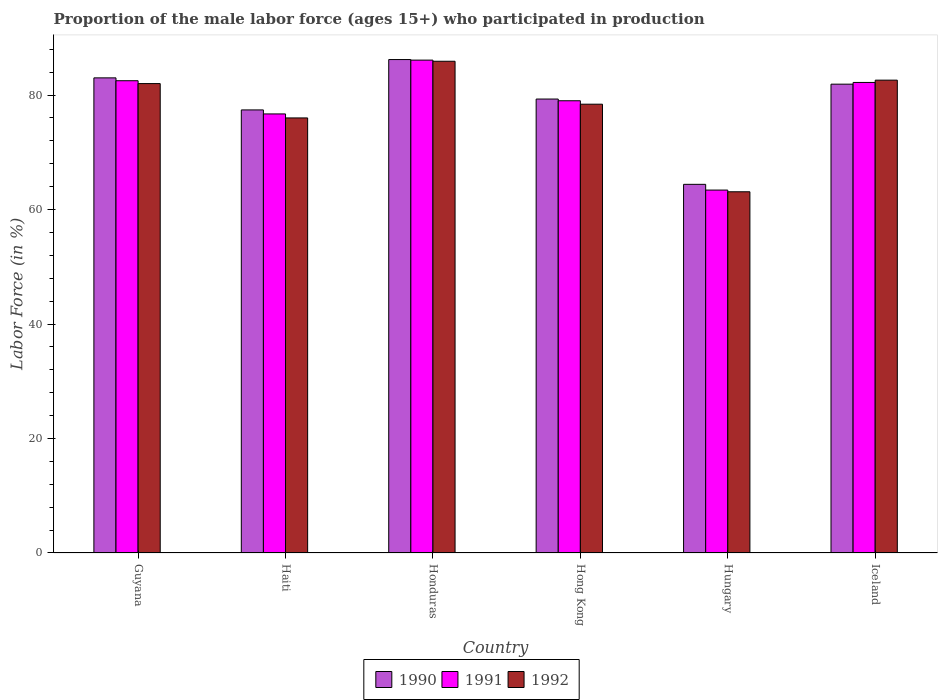How many different coloured bars are there?
Your answer should be very brief. 3. How many groups of bars are there?
Offer a terse response. 6. How many bars are there on the 2nd tick from the left?
Offer a terse response. 3. What is the label of the 2nd group of bars from the left?
Provide a short and direct response. Haiti. What is the proportion of the male labor force who participated in production in 1990 in Hong Kong?
Ensure brevity in your answer.  79.3. Across all countries, what is the maximum proportion of the male labor force who participated in production in 1990?
Provide a succinct answer. 86.2. Across all countries, what is the minimum proportion of the male labor force who participated in production in 1992?
Your answer should be very brief. 63.1. In which country was the proportion of the male labor force who participated in production in 1991 maximum?
Provide a succinct answer. Honduras. In which country was the proportion of the male labor force who participated in production in 1991 minimum?
Your answer should be very brief. Hungary. What is the total proportion of the male labor force who participated in production in 1991 in the graph?
Provide a short and direct response. 469.9. What is the difference between the proportion of the male labor force who participated in production in 1992 in Hong Kong and that in Iceland?
Offer a very short reply. -4.2. What is the difference between the proportion of the male labor force who participated in production in 1991 in Hungary and the proportion of the male labor force who participated in production in 1992 in Hong Kong?
Give a very brief answer. -15. What is the average proportion of the male labor force who participated in production in 1991 per country?
Your response must be concise. 78.32. What is the difference between the proportion of the male labor force who participated in production of/in 1991 and proportion of the male labor force who participated in production of/in 1992 in Honduras?
Offer a very short reply. 0.2. In how many countries, is the proportion of the male labor force who participated in production in 1990 greater than 12 %?
Offer a terse response. 6. What is the ratio of the proportion of the male labor force who participated in production in 1990 in Guyana to that in Iceland?
Provide a succinct answer. 1.01. Is the proportion of the male labor force who participated in production in 1990 in Honduras less than that in Hungary?
Offer a very short reply. No. Is the difference between the proportion of the male labor force who participated in production in 1991 in Hungary and Iceland greater than the difference between the proportion of the male labor force who participated in production in 1992 in Hungary and Iceland?
Your answer should be compact. Yes. What is the difference between the highest and the second highest proportion of the male labor force who participated in production in 1991?
Offer a very short reply. 0.3. What is the difference between the highest and the lowest proportion of the male labor force who participated in production in 1990?
Ensure brevity in your answer.  21.8. Is the sum of the proportion of the male labor force who participated in production in 1991 in Honduras and Hong Kong greater than the maximum proportion of the male labor force who participated in production in 1990 across all countries?
Ensure brevity in your answer.  Yes. What does the 1st bar from the right in Honduras represents?
Your response must be concise. 1992. Is it the case that in every country, the sum of the proportion of the male labor force who participated in production in 1990 and proportion of the male labor force who participated in production in 1992 is greater than the proportion of the male labor force who participated in production in 1991?
Offer a very short reply. Yes. How many bars are there?
Offer a terse response. 18. Are all the bars in the graph horizontal?
Your answer should be compact. No. Does the graph contain any zero values?
Give a very brief answer. No. How many legend labels are there?
Provide a short and direct response. 3. How are the legend labels stacked?
Offer a very short reply. Horizontal. What is the title of the graph?
Offer a terse response. Proportion of the male labor force (ages 15+) who participated in production. What is the label or title of the X-axis?
Your answer should be compact. Country. What is the Labor Force (in %) of 1990 in Guyana?
Provide a succinct answer. 83. What is the Labor Force (in %) of 1991 in Guyana?
Give a very brief answer. 82.5. What is the Labor Force (in %) in 1990 in Haiti?
Ensure brevity in your answer.  77.4. What is the Labor Force (in %) in 1991 in Haiti?
Your answer should be very brief. 76.7. What is the Labor Force (in %) of 1992 in Haiti?
Your answer should be compact. 76. What is the Labor Force (in %) in 1990 in Honduras?
Offer a terse response. 86.2. What is the Labor Force (in %) of 1991 in Honduras?
Provide a short and direct response. 86.1. What is the Labor Force (in %) in 1992 in Honduras?
Ensure brevity in your answer.  85.9. What is the Labor Force (in %) in 1990 in Hong Kong?
Offer a very short reply. 79.3. What is the Labor Force (in %) of 1991 in Hong Kong?
Make the answer very short. 79. What is the Labor Force (in %) of 1992 in Hong Kong?
Ensure brevity in your answer.  78.4. What is the Labor Force (in %) of 1990 in Hungary?
Offer a terse response. 64.4. What is the Labor Force (in %) of 1991 in Hungary?
Offer a very short reply. 63.4. What is the Labor Force (in %) of 1992 in Hungary?
Offer a very short reply. 63.1. What is the Labor Force (in %) in 1990 in Iceland?
Keep it short and to the point. 81.9. What is the Labor Force (in %) in 1991 in Iceland?
Your response must be concise. 82.2. What is the Labor Force (in %) in 1992 in Iceland?
Provide a short and direct response. 82.6. Across all countries, what is the maximum Labor Force (in %) in 1990?
Ensure brevity in your answer.  86.2. Across all countries, what is the maximum Labor Force (in %) in 1991?
Your answer should be compact. 86.1. Across all countries, what is the maximum Labor Force (in %) in 1992?
Provide a succinct answer. 85.9. Across all countries, what is the minimum Labor Force (in %) in 1990?
Make the answer very short. 64.4. Across all countries, what is the minimum Labor Force (in %) of 1991?
Make the answer very short. 63.4. Across all countries, what is the minimum Labor Force (in %) of 1992?
Offer a very short reply. 63.1. What is the total Labor Force (in %) of 1990 in the graph?
Offer a terse response. 472.2. What is the total Labor Force (in %) in 1991 in the graph?
Your response must be concise. 469.9. What is the total Labor Force (in %) in 1992 in the graph?
Keep it short and to the point. 468. What is the difference between the Labor Force (in %) of 1992 in Guyana and that in Haiti?
Ensure brevity in your answer.  6. What is the difference between the Labor Force (in %) in 1991 in Guyana and that in Hong Kong?
Give a very brief answer. 3.5. What is the difference between the Labor Force (in %) of 1992 in Guyana and that in Hong Kong?
Provide a short and direct response. 3.6. What is the difference between the Labor Force (in %) of 1990 in Guyana and that in Hungary?
Keep it short and to the point. 18.6. What is the difference between the Labor Force (in %) of 1992 in Guyana and that in Hungary?
Make the answer very short. 18.9. What is the difference between the Labor Force (in %) in 1990 in Guyana and that in Iceland?
Make the answer very short. 1.1. What is the difference between the Labor Force (in %) in 1991 in Guyana and that in Iceland?
Ensure brevity in your answer.  0.3. What is the difference between the Labor Force (in %) of 1990 in Haiti and that in Honduras?
Provide a succinct answer. -8.8. What is the difference between the Labor Force (in %) in 1992 in Haiti and that in Honduras?
Give a very brief answer. -9.9. What is the difference between the Labor Force (in %) in 1991 in Haiti and that in Hong Kong?
Offer a terse response. -2.3. What is the difference between the Labor Force (in %) of 1990 in Haiti and that in Hungary?
Give a very brief answer. 13. What is the difference between the Labor Force (in %) in 1991 in Haiti and that in Hungary?
Make the answer very short. 13.3. What is the difference between the Labor Force (in %) in 1992 in Haiti and that in Hungary?
Ensure brevity in your answer.  12.9. What is the difference between the Labor Force (in %) in 1990 in Haiti and that in Iceland?
Provide a short and direct response. -4.5. What is the difference between the Labor Force (in %) in 1991 in Haiti and that in Iceland?
Ensure brevity in your answer.  -5.5. What is the difference between the Labor Force (in %) of 1990 in Honduras and that in Hungary?
Your answer should be very brief. 21.8. What is the difference between the Labor Force (in %) of 1991 in Honduras and that in Hungary?
Your response must be concise. 22.7. What is the difference between the Labor Force (in %) in 1992 in Honduras and that in Hungary?
Offer a terse response. 22.8. What is the difference between the Labor Force (in %) in 1991 in Honduras and that in Iceland?
Provide a succinct answer. 3.9. What is the difference between the Labor Force (in %) in 1990 in Hong Kong and that in Hungary?
Offer a very short reply. 14.9. What is the difference between the Labor Force (in %) of 1992 in Hong Kong and that in Hungary?
Your answer should be very brief. 15.3. What is the difference between the Labor Force (in %) in 1990 in Hong Kong and that in Iceland?
Your response must be concise. -2.6. What is the difference between the Labor Force (in %) of 1991 in Hong Kong and that in Iceland?
Provide a short and direct response. -3.2. What is the difference between the Labor Force (in %) in 1992 in Hong Kong and that in Iceland?
Provide a short and direct response. -4.2. What is the difference between the Labor Force (in %) in 1990 in Hungary and that in Iceland?
Keep it short and to the point. -17.5. What is the difference between the Labor Force (in %) in 1991 in Hungary and that in Iceland?
Give a very brief answer. -18.8. What is the difference between the Labor Force (in %) of 1992 in Hungary and that in Iceland?
Make the answer very short. -19.5. What is the difference between the Labor Force (in %) in 1990 in Guyana and the Labor Force (in %) in 1992 in Haiti?
Offer a terse response. 7. What is the difference between the Labor Force (in %) of 1990 in Guyana and the Labor Force (in %) of 1991 in Honduras?
Give a very brief answer. -3.1. What is the difference between the Labor Force (in %) in 1991 in Guyana and the Labor Force (in %) in 1992 in Honduras?
Provide a short and direct response. -3.4. What is the difference between the Labor Force (in %) in 1990 in Guyana and the Labor Force (in %) in 1991 in Hungary?
Provide a succinct answer. 19.6. What is the difference between the Labor Force (in %) of 1991 in Guyana and the Labor Force (in %) of 1992 in Hungary?
Give a very brief answer. 19.4. What is the difference between the Labor Force (in %) in 1990 in Guyana and the Labor Force (in %) in 1992 in Iceland?
Keep it short and to the point. 0.4. What is the difference between the Labor Force (in %) in 1991 in Haiti and the Labor Force (in %) in 1992 in Honduras?
Provide a succinct answer. -9.2. What is the difference between the Labor Force (in %) of 1990 in Haiti and the Labor Force (in %) of 1992 in Hong Kong?
Your answer should be compact. -1. What is the difference between the Labor Force (in %) in 1991 in Haiti and the Labor Force (in %) in 1992 in Hong Kong?
Make the answer very short. -1.7. What is the difference between the Labor Force (in %) of 1991 in Haiti and the Labor Force (in %) of 1992 in Hungary?
Give a very brief answer. 13.6. What is the difference between the Labor Force (in %) in 1991 in Haiti and the Labor Force (in %) in 1992 in Iceland?
Provide a short and direct response. -5.9. What is the difference between the Labor Force (in %) of 1990 in Honduras and the Labor Force (in %) of 1991 in Hong Kong?
Provide a succinct answer. 7.2. What is the difference between the Labor Force (in %) of 1990 in Honduras and the Labor Force (in %) of 1992 in Hong Kong?
Give a very brief answer. 7.8. What is the difference between the Labor Force (in %) in 1990 in Honduras and the Labor Force (in %) in 1991 in Hungary?
Your response must be concise. 22.8. What is the difference between the Labor Force (in %) in 1990 in Honduras and the Labor Force (in %) in 1992 in Hungary?
Keep it short and to the point. 23.1. What is the difference between the Labor Force (in %) of 1991 in Honduras and the Labor Force (in %) of 1992 in Hungary?
Offer a terse response. 23. What is the difference between the Labor Force (in %) in 1990 in Honduras and the Labor Force (in %) in 1991 in Iceland?
Ensure brevity in your answer.  4. What is the difference between the Labor Force (in %) in 1990 in Honduras and the Labor Force (in %) in 1992 in Iceland?
Keep it short and to the point. 3.6. What is the difference between the Labor Force (in %) of 1990 in Hong Kong and the Labor Force (in %) of 1992 in Hungary?
Your answer should be compact. 16.2. What is the difference between the Labor Force (in %) in 1991 in Hong Kong and the Labor Force (in %) in 1992 in Hungary?
Give a very brief answer. 15.9. What is the difference between the Labor Force (in %) of 1990 in Hong Kong and the Labor Force (in %) of 1991 in Iceland?
Ensure brevity in your answer.  -2.9. What is the difference between the Labor Force (in %) in 1990 in Hong Kong and the Labor Force (in %) in 1992 in Iceland?
Offer a very short reply. -3.3. What is the difference between the Labor Force (in %) of 1991 in Hong Kong and the Labor Force (in %) of 1992 in Iceland?
Offer a terse response. -3.6. What is the difference between the Labor Force (in %) of 1990 in Hungary and the Labor Force (in %) of 1991 in Iceland?
Offer a very short reply. -17.8. What is the difference between the Labor Force (in %) in 1990 in Hungary and the Labor Force (in %) in 1992 in Iceland?
Make the answer very short. -18.2. What is the difference between the Labor Force (in %) of 1991 in Hungary and the Labor Force (in %) of 1992 in Iceland?
Your response must be concise. -19.2. What is the average Labor Force (in %) of 1990 per country?
Keep it short and to the point. 78.7. What is the average Labor Force (in %) in 1991 per country?
Give a very brief answer. 78.32. What is the difference between the Labor Force (in %) in 1990 and Labor Force (in %) in 1992 in Haiti?
Your response must be concise. 1.4. What is the difference between the Labor Force (in %) of 1990 and Labor Force (in %) of 1992 in Honduras?
Your answer should be very brief. 0.3. What is the difference between the Labor Force (in %) in 1991 and Labor Force (in %) in 1992 in Honduras?
Your answer should be compact. 0.2. What is the difference between the Labor Force (in %) in 1990 and Labor Force (in %) in 1991 in Hong Kong?
Provide a short and direct response. 0.3. What is the difference between the Labor Force (in %) in 1990 and Labor Force (in %) in 1991 in Hungary?
Provide a succinct answer. 1. What is the difference between the Labor Force (in %) of 1990 and Labor Force (in %) of 1992 in Hungary?
Provide a succinct answer. 1.3. What is the difference between the Labor Force (in %) of 1991 and Labor Force (in %) of 1992 in Hungary?
Ensure brevity in your answer.  0.3. What is the difference between the Labor Force (in %) in 1990 and Labor Force (in %) in 1991 in Iceland?
Make the answer very short. -0.3. What is the ratio of the Labor Force (in %) of 1990 in Guyana to that in Haiti?
Your response must be concise. 1.07. What is the ratio of the Labor Force (in %) of 1991 in Guyana to that in Haiti?
Your answer should be compact. 1.08. What is the ratio of the Labor Force (in %) of 1992 in Guyana to that in Haiti?
Offer a very short reply. 1.08. What is the ratio of the Labor Force (in %) in 1990 in Guyana to that in Honduras?
Your answer should be compact. 0.96. What is the ratio of the Labor Force (in %) in 1991 in Guyana to that in Honduras?
Ensure brevity in your answer.  0.96. What is the ratio of the Labor Force (in %) in 1992 in Guyana to that in Honduras?
Offer a terse response. 0.95. What is the ratio of the Labor Force (in %) in 1990 in Guyana to that in Hong Kong?
Your answer should be very brief. 1.05. What is the ratio of the Labor Force (in %) of 1991 in Guyana to that in Hong Kong?
Make the answer very short. 1.04. What is the ratio of the Labor Force (in %) in 1992 in Guyana to that in Hong Kong?
Ensure brevity in your answer.  1.05. What is the ratio of the Labor Force (in %) in 1990 in Guyana to that in Hungary?
Ensure brevity in your answer.  1.29. What is the ratio of the Labor Force (in %) of 1991 in Guyana to that in Hungary?
Your response must be concise. 1.3. What is the ratio of the Labor Force (in %) in 1992 in Guyana to that in Hungary?
Keep it short and to the point. 1.3. What is the ratio of the Labor Force (in %) in 1990 in Guyana to that in Iceland?
Your answer should be compact. 1.01. What is the ratio of the Labor Force (in %) of 1990 in Haiti to that in Honduras?
Give a very brief answer. 0.9. What is the ratio of the Labor Force (in %) in 1991 in Haiti to that in Honduras?
Make the answer very short. 0.89. What is the ratio of the Labor Force (in %) of 1992 in Haiti to that in Honduras?
Your response must be concise. 0.88. What is the ratio of the Labor Force (in %) of 1991 in Haiti to that in Hong Kong?
Provide a short and direct response. 0.97. What is the ratio of the Labor Force (in %) of 1992 in Haiti to that in Hong Kong?
Give a very brief answer. 0.97. What is the ratio of the Labor Force (in %) of 1990 in Haiti to that in Hungary?
Keep it short and to the point. 1.2. What is the ratio of the Labor Force (in %) in 1991 in Haiti to that in Hungary?
Keep it short and to the point. 1.21. What is the ratio of the Labor Force (in %) in 1992 in Haiti to that in Hungary?
Provide a short and direct response. 1.2. What is the ratio of the Labor Force (in %) in 1990 in Haiti to that in Iceland?
Provide a succinct answer. 0.95. What is the ratio of the Labor Force (in %) in 1991 in Haiti to that in Iceland?
Give a very brief answer. 0.93. What is the ratio of the Labor Force (in %) in 1992 in Haiti to that in Iceland?
Make the answer very short. 0.92. What is the ratio of the Labor Force (in %) of 1990 in Honduras to that in Hong Kong?
Your answer should be compact. 1.09. What is the ratio of the Labor Force (in %) of 1991 in Honduras to that in Hong Kong?
Give a very brief answer. 1.09. What is the ratio of the Labor Force (in %) of 1992 in Honduras to that in Hong Kong?
Your response must be concise. 1.1. What is the ratio of the Labor Force (in %) of 1990 in Honduras to that in Hungary?
Give a very brief answer. 1.34. What is the ratio of the Labor Force (in %) in 1991 in Honduras to that in Hungary?
Keep it short and to the point. 1.36. What is the ratio of the Labor Force (in %) in 1992 in Honduras to that in Hungary?
Make the answer very short. 1.36. What is the ratio of the Labor Force (in %) in 1990 in Honduras to that in Iceland?
Offer a terse response. 1.05. What is the ratio of the Labor Force (in %) of 1991 in Honduras to that in Iceland?
Your answer should be very brief. 1.05. What is the ratio of the Labor Force (in %) in 1992 in Honduras to that in Iceland?
Give a very brief answer. 1.04. What is the ratio of the Labor Force (in %) of 1990 in Hong Kong to that in Hungary?
Offer a very short reply. 1.23. What is the ratio of the Labor Force (in %) in 1991 in Hong Kong to that in Hungary?
Ensure brevity in your answer.  1.25. What is the ratio of the Labor Force (in %) in 1992 in Hong Kong to that in Hungary?
Your answer should be compact. 1.24. What is the ratio of the Labor Force (in %) in 1990 in Hong Kong to that in Iceland?
Make the answer very short. 0.97. What is the ratio of the Labor Force (in %) of 1991 in Hong Kong to that in Iceland?
Your response must be concise. 0.96. What is the ratio of the Labor Force (in %) in 1992 in Hong Kong to that in Iceland?
Offer a very short reply. 0.95. What is the ratio of the Labor Force (in %) of 1990 in Hungary to that in Iceland?
Make the answer very short. 0.79. What is the ratio of the Labor Force (in %) of 1991 in Hungary to that in Iceland?
Give a very brief answer. 0.77. What is the ratio of the Labor Force (in %) in 1992 in Hungary to that in Iceland?
Provide a short and direct response. 0.76. What is the difference between the highest and the second highest Labor Force (in %) of 1990?
Provide a succinct answer. 3.2. What is the difference between the highest and the lowest Labor Force (in %) in 1990?
Your response must be concise. 21.8. What is the difference between the highest and the lowest Labor Force (in %) in 1991?
Provide a succinct answer. 22.7. What is the difference between the highest and the lowest Labor Force (in %) of 1992?
Make the answer very short. 22.8. 